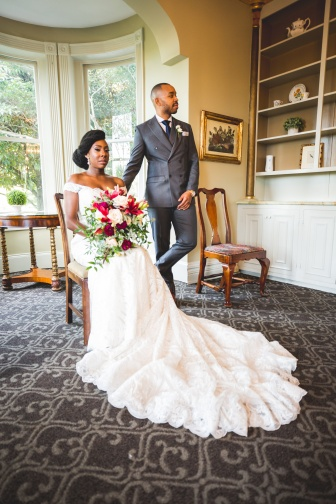Describe what the bride and groom might be thinking in this moment. The bride might be feeling a mixture of joy and anticipation as she contemplates their future together. The groom, gazing at her with affection, likely feels immense love and gratitude for the special moments they have shared and the lifetime they will build together. What kind of story do you imagine for the couple based on their surroundings? The couple seems to have chosen a classic and timeless setting for their special day, indicating a taste for elegance and tradition. Perhaps they met in a charming, old-fashioned library, sharing a love for literature and history. Over time, they built a deep connection through their shared interests, leading to this beautiful moment where they are surrounded by an environment that reflects their shared passions and timeless love. Imagine the couple's first dance and describe it in detail. Their first dance takes place in a beautifully adorned ballroom, with soft, golden light emanating from elegant chandeliers above. The bride's dress flows ethereally as they move to the rhythm of a classic love song, their gazes locked in a moment of pure connection. Surrounded by friends and family, they glide across the floor, lost in their own world, as the music swells and echoes through the hall. The groom holds her gently, leading her through each step with grace and precision, reflecting the deep understanding and love they have for each other. As the dance progresses, they share whispered words and soft smiles, creating a memory that will be cherished for a lifetime. 